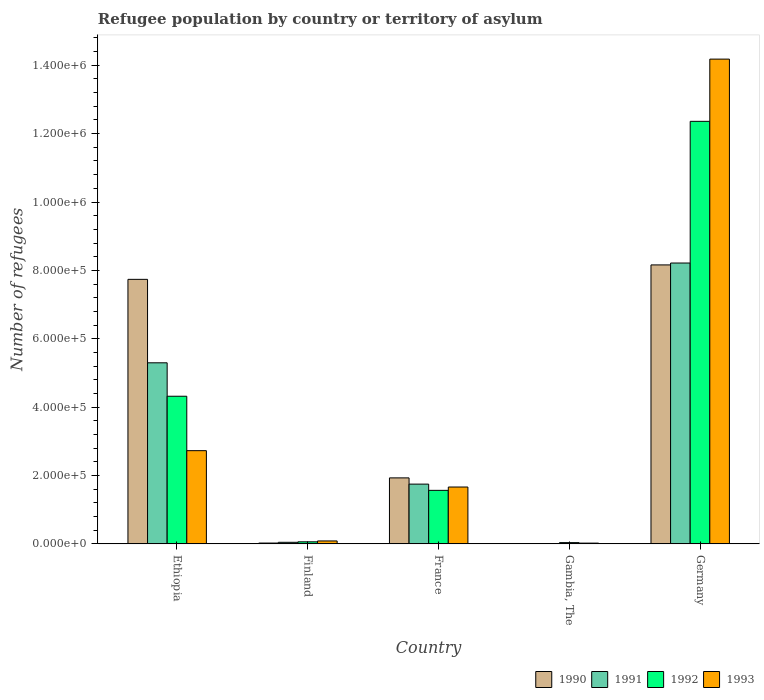How many groups of bars are there?
Offer a very short reply. 5. Are the number of bars per tick equal to the number of legend labels?
Your answer should be very brief. Yes. Are the number of bars on each tick of the X-axis equal?
Your answer should be compact. Yes. How many bars are there on the 3rd tick from the left?
Ensure brevity in your answer.  4. What is the label of the 4th group of bars from the left?
Keep it short and to the point. Gambia, The. In how many cases, is the number of bars for a given country not equal to the number of legend labels?
Offer a terse response. 0. What is the number of refugees in 1993 in Gambia, The?
Ensure brevity in your answer.  2190. Across all countries, what is the maximum number of refugees in 1991?
Your answer should be compact. 8.22e+05. In which country was the number of refugees in 1993 maximum?
Your answer should be very brief. Germany. In which country was the number of refugees in 1990 minimum?
Your answer should be very brief. Gambia, The. What is the total number of refugees in 1990 in the graph?
Ensure brevity in your answer.  1.79e+06. What is the difference between the number of refugees in 1993 in France and that in Gambia, The?
Your answer should be compact. 1.64e+05. What is the difference between the number of refugees in 1992 in Gambia, The and the number of refugees in 1990 in Germany?
Offer a terse response. -8.12e+05. What is the average number of refugees in 1990 per country?
Offer a terse response. 3.57e+05. What is the difference between the number of refugees of/in 1992 and number of refugees of/in 1990 in Finland?
Offer a very short reply. 3602. What is the ratio of the number of refugees in 1993 in France to that in Gambia, The?
Offer a very short reply. 75.92. Is the number of refugees in 1992 in Finland less than that in Gambia, The?
Make the answer very short. No. What is the difference between the highest and the second highest number of refugees in 1993?
Offer a terse response. 1.25e+06. What is the difference between the highest and the lowest number of refugees in 1992?
Offer a terse response. 1.23e+06. In how many countries, is the number of refugees in 1993 greater than the average number of refugees in 1993 taken over all countries?
Ensure brevity in your answer.  1. Is the sum of the number of refugees in 1992 in Ethiopia and France greater than the maximum number of refugees in 1990 across all countries?
Your response must be concise. No. Is it the case that in every country, the sum of the number of refugees in 1992 and number of refugees in 1991 is greater than the sum of number of refugees in 1990 and number of refugees in 1993?
Provide a succinct answer. No. What does the 2nd bar from the left in Germany represents?
Provide a succinct answer. 1991. What does the 4th bar from the right in Ethiopia represents?
Offer a very short reply. 1990. How many bars are there?
Keep it short and to the point. 20. Are all the bars in the graph horizontal?
Offer a very short reply. No. How many countries are there in the graph?
Keep it short and to the point. 5. What is the difference between two consecutive major ticks on the Y-axis?
Ensure brevity in your answer.  2.00e+05. Are the values on the major ticks of Y-axis written in scientific E-notation?
Your response must be concise. Yes. Where does the legend appear in the graph?
Offer a very short reply. Bottom right. What is the title of the graph?
Ensure brevity in your answer.  Refugee population by country or territory of asylum. What is the label or title of the X-axis?
Keep it short and to the point. Country. What is the label or title of the Y-axis?
Offer a very short reply. Number of refugees. What is the Number of refugees of 1990 in Ethiopia?
Give a very brief answer. 7.74e+05. What is the Number of refugees in 1991 in Ethiopia?
Your answer should be very brief. 5.30e+05. What is the Number of refugees in 1992 in Ethiopia?
Your answer should be compact. 4.32e+05. What is the Number of refugees of 1993 in Ethiopia?
Keep it short and to the point. 2.73e+05. What is the Number of refugees of 1990 in Finland?
Your answer should be compact. 2348. What is the Number of refugees of 1991 in Finland?
Your answer should be very brief. 4561. What is the Number of refugees in 1992 in Finland?
Offer a very short reply. 5950. What is the Number of refugees in 1993 in Finland?
Keep it short and to the point. 8511. What is the Number of refugees in 1990 in France?
Provide a succinct answer. 1.93e+05. What is the Number of refugees of 1991 in France?
Keep it short and to the point. 1.75e+05. What is the Number of refugees of 1992 in France?
Your answer should be compact. 1.57e+05. What is the Number of refugees in 1993 in France?
Keep it short and to the point. 1.66e+05. What is the Number of refugees in 1990 in Gambia, The?
Make the answer very short. 78. What is the Number of refugees of 1991 in Gambia, The?
Your answer should be very brief. 241. What is the Number of refugees of 1992 in Gambia, The?
Keep it short and to the point. 3632. What is the Number of refugees in 1993 in Gambia, The?
Your answer should be very brief. 2190. What is the Number of refugees in 1990 in Germany?
Offer a very short reply. 8.16e+05. What is the Number of refugees of 1991 in Germany?
Offer a terse response. 8.22e+05. What is the Number of refugees in 1992 in Germany?
Ensure brevity in your answer.  1.24e+06. What is the Number of refugees of 1993 in Germany?
Keep it short and to the point. 1.42e+06. Across all countries, what is the maximum Number of refugees of 1990?
Give a very brief answer. 8.16e+05. Across all countries, what is the maximum Number of refugees in 1991?
Keep it short and to the point. 8.22e+05. Across all countries, what is the maximum Number of refugees in 1992?
Your answer should be very brief. 1.24e+06. Across all countries, what is the maximum Number of refugees of 1993?
Provide a short and direct response. 1.42e+06. Across all countries, what is the minimum Number of refugees in 1990?
Provide a succinct answer. 78. Across all countries, what is the minimum Number of refugees of 1991?
Your answer should be compact. 241. Across all countries, what is the minimum Number of refugees of 1992?
Provide a short and direct response. 3632. Across all countries, what is the minimum Number of refugees in 1993?
Make the answer very short. 2190. What is the total Number of refugees in 1990 in the graph?
Give a very brief answer. 1.79e+06. What is the total Number of refugees in 1991 in the graph?
Provide a succinct answer. 1.53e+06. What is the total Number of refugees of 1992 in the graph?
Offer a terse response. 1.83e+06. What is the total Number of refugees of 1993 in the graph?
Offer a very short reply. 1.87e+06. What is the difference between the Number of refugees of 1990 in Ethiopia and that in Finland?
Provide a short and direct response. 7.71e+05. What is the difference between the Number of refugees of 1991 in Ethiopia and that in Finland?
Your answer should be compact. 5.25e+05. What is the difference between the Number of refugees in 1992 in Ethiopia and that in Finland?
Keep it short and to the point. 4.26e+05. What is the difference between the Number of refugees of 1993 in Ethiopia and that in Finland?
Offer a very short reply. 2.64e+05. What is the difference between the Number of refugees in 1990 in Ethiopia and that in France?
Offer a terse response. 5.81e+05. What is the difference between the Number of refugees of 1991 in Ethiopia and that in France?
Your answer should be compact. 3.55e+05. What is the difference between the Number of refugees in 1992 in Ethiopia and that in France?
Your answer should be compact. 2.75e+05. What is the difference between the Number of refugees in 1993 in Ethiopia and that in France?
Give a very brief answer. 1.06e+05. What is the difference between the Number of refugees of 1990 in Ethiopia and that in Gambia, The?
Ensure brevity in your answer.  7.74e+05. What is the difference between the Number of refugees of 1991 in Ethiopia and that in Gambia, The?
Your response must be concise. 5.29e+05. What is the difference between the Number of refugees of 1992 in Ethiopia and that in Gambia, The?
Keep it short and to the point. 4.28e+05. What is the difference between the Number of refugees in 1993 in Ethiopia and that in Gambia, The?
Offer a terse response. 2.70e+05. What is the difference between the Number of refugees in 1990 in Ethiopia and that in Germany?
Provide a short and direct response. -4.22e+04. What is the difference between the Number of refugees in 1991 in Ethiopia and that in Germany?
Offer a terse response. -2.92e+05. What is the difference between the Number of refugees of 1992 in Ethiopia and that in Germany?
Offer a terse response. -8.04e+05. What is the difference between the Number of refugees of 1993 in Ethiopia and that in Germany?
Provide a succinct answer. -1.15e+06. What is the difference between the Number of refugees in 1990 in Finland and that in France?
Your answer should be compact. -1.91e+05. What is the difference between the Number of refugees in 1991 in Finland and that in France?
Provide a succinct answer. -1.70e+05. What is the difference between the Number of refugees of 1992 in Finland and that in France?
Offer a very short reply. -1.51e+05. What is the difference between the Number of refugees of 1993 in Finland and that in France?
Your answer should be very brief. -1.58e+05. What is the difference between the Number of refugees in 1990 in Finland and that in Gambia, The?
Ensure brevity in your answer.  2270. What is the difference between the Number of refugees of 1991 in Finland and that in Gambia, The?
Your answer should be compact. 4320. What is the difference between the Number of refugees of 1992 in Finland and that in Gambia, The?
Keep it short and to the point. 2318. What is the difference between the Number of refugees of 1993 in Finland and that in Gambia, The?
Provide a succinct answer. 6321. What is the difference between the Number of refugees in 1990 in Finland and that in Germany?
Offer a terse response. -8.14e+05. What is the difference between the Number of refugees in 1991 in Finland and that in Germany?
Your response must be concise. -8.17e+05. What is the difference between the Number of refugees of 1992 in Finland and that in Germany?
Your response must be concise. -1.23e+06. What is the difference between the Number of refugees in 1993 in Finland and that in Germany?
Ensure brevity in your answer.  -1.41e+06. What is the difference between the Number of refugees in 1990 in France and that in Gambia, The?
Make the answer very short. 1.93e+05. What is the difference between the Number of refugees of 1991 in France and that in Gambia, The?
Ensure brevity in your answer.  1.75e+05. What is the difference between the Number of refugees of 1992 in France and that in Gambia, The?
Provide a short and direct response. 1.53e+05. What is the difference between the Number of refugees of 1993 in France and that in Gambia, The?
Keep it short and to the point. 1.64e+05. What is the difference between the Number of refugees in 1990 in France and that in Germany?
Your answer should be very brief. -6.23e+05. What is the difference between the Number of refugees in 1991 in France and that in Germany?
Provide a short and direct response. -6.47e+05. What is the difference between the Number of refugees in 1992 in France and that in Germany?
Offer a terse response. -1.08e+06. What is the difference between the Number of refugees of 1993 in France and that in Germany?
Offer a very short reply. -1.25e+06. What is the difference between the Number of refugees in 1990 in Gambia, The and that in Germany?
Your answer should be very brief. -8.16e+05. What is the difference between the Number of refugees in 1991 in Gambia, The and that in Germany?
Give a very brief answer. -8.21e+05. What is the difference between the Number of refugees of 1992 in Gambia, The and that in Germany?
Ensure brevity in your answer.  -1.23e+06. What is the difference between the Number of refugees in 1993 in Gambia, The and that in Germany?
Provide a succinct answer. -1.42e+06. What is the difference between the Number of refugees of 1990 in Ethiopia and the Number of refugees of 1991 in Finland?
Keep it short and to the point. 7.69e+05. What is the difference between the Number of refugees of 1990 in Ethiopia and the Number of refugees of 1992 in Finland?
Provide a short and direct response. 7.68e+05. What is the difference between the Number of refugees of 1990 in Ethiopia and the Number of refugees of 1993 in Finland?
Provide a short and direct response. 7.65e+05. What is the difference between the Number of refugees in 1991 in Ethiopia and the Number of refugees in 1992 in Finland?
Your answer should be compact. 5.24e+05. What is the difference between the Number of refugees of 1991 in Ethiopia and the Number of refugees of 1993 in Finland?
Ensure brevity in your answer.  5.21e+05. What is the difference between the Number of refugees in 1992 in Ethiopia and the Number of refugees in 1993 in Finland?
Your response must be concise. 4.23e+05. What is the difference between the Number of refugees in 1990 in Ethiopia and the Number of refugees in 1991 in France?
Offer a very short reply. 5.99e+05. What is the difference between the Number of refugees of 1990 in Ethiopia and the Number of refugees of 1992 in France?
Give a very brief answer. 6.17e+05. What is the difference between the Number of refugees in 1990 in Ethiopia and the Number of refugees in 1993 in France?
Your answer should be very brief. 6.07e+05. What is the difference between the Number of refugees in 1991 in Ethiopia and the Number of refugees in 1992 in France?
Offer a terse response. 3.73e+05. What is the difference between the Number of refugees of 1991 in Ethiopia and the Number of refugees of 1993 in France?
Make the answer very short. 3.63e+05. What is the difference between the Number of refugees of 1992 in Ethiopia and the Number of refugees of 1993 in France?
Keep it short and to the point. 2.66e+05. What is the difference between the Number of refugees in 1990 in Ethiopia and the Number of refugees in 1991 in Gambia, The?
Provide a short and direct response. 7.74e+05. What is the difference between the Number of refugees in 1990 in Ethiopia and the Number of refugees in 1992 in Gambia, The?
Your answer should be compact. 7.70e+05. What is the difference between the Number of refugees in 1990 in Ethiopia and the Number of refugees in 1993 in Gambia, The?
Offer a very short reply. 7.72e+05. What is the difference between the Number of refugees in 1991 in Ethiopia and the Number of refugees in 1992 in Gambia, The?
Provide a succinct answer. 5.26e+05. What is the difference between the Number of refugees of 1991 in Ethiopia and the Number of refugees of 1993 in Gambia, The?
Make the answer very short. 5.27e+05. What is the difference between the Number of refugees in 1992 in Ethiopia and the Number of refugees in 1993 in Gambia, The?
Your response must be concise. 4.30e+05. What is the difference between the Number of refugees in 1990 in Ethiopia and the Number of refugees in 1991 in Germany?
Your response must be concise. -4.77e+04. What is the difference between the Number of refugees of 1990 in Ethiopia and the Number of refugees of 1992 in Germany?
Your response must be concise. -4.62e+05. What is the difference between the Number of refugees in 1990 in Ethiopia and the Number of refugees in 1993 in Germany?
Your answer should be compact. -6.44e+05. What is the difference between the Number of refugees in 1991 in Ethiopia and the Number of refugees in 1992 in Germany?
Offer a very short reply. -7.06e+05. What is the difference between the Number of refugees in 1991 in Ethiopia and the Number of refugees in 1993 in Germany?
Keep it short and to the point. -8.88e+05. What is the difference between the Number of refugees in 1992 in Ethiopia and the Number of refugees in 1993 in Germany?
Ensure brevity in your answer.  -9.86e+05. What is the difference between the Number of refugees of 1990 in Finland and the Number of refugees of 1991 in France?
Offer a very short reply. -1.72e+05. What is the difference between the Number of refugees of 1990 in Finland and the Number of refugees of 1992 in France?
Offer a very short reply. -1.54e+05. What is the difference between the Number of refugees of 1990 in Finland and the Number of refugees of 1993 in France?
Provide a succinct answer. -1.64e+05. What is the difference between the Number of refugees in 1991 in Finland and the Number of refugees in 1992 in France?
Offer a terse response. -1.52e+05. What is the difference between the Number of refugees of 1991 in Finland and the Number of refugees of 1993 in France?
Ensure brevity in your answer.  -1.62e+05. What is the difference between the Number of refugees in 1992 in Finland and the Number of refugees in 1993 in France?
Your response must be concise. -1.60e+05. What is the difference between the Number of refugees of 1990 in Finland and the Number of refugees of 1991 in Gambia, The?
Make the answer very short. 2107. What is the difference between the Number of refugees in 1990 in Finland and the Number of refugees in 1992 in Gambia, The?
Make the answer very short. -1284. What is the difference between the Number of refugees of 1990 in Finland and the Number of refugees of 1993 in Gambia, The?
Offer a very short reply. 158. What is the difference between the Number of refugees in 1991 in Finland and the Number of refugees in 1992 in Gambia, The?
Keep it short and to the point. 929. What is the difference between the Number of refugees in 1991 in Finland and the Number of refugees in 1993 in Gambia, The?
Provide a short and direct response. 2371. What is the difference between the Number of refugees in 1992 in Finland and the Number of refugees in 1993 in Gambia, The?
Your answer should be very brief. 3760. What is the difference between the Number of refugees in 1990 in Finland and the Number of refugees in 1991 in Germany?
Ensure brevity in your answer.  -8.19e+05. What is the difference between the Number of refugees in 1990 in Finland and the Number of refugees in 1992 in Germany?
Provide a succinct answer. -1.23e+06. What is the difference between the Number of refugees of 1990 in Finland and the Number of refugees of 1993 in Germany?
Give a very brief answer. -1.42e+06. What is the difference between the Number of refugees of 1991 in Finland and the Number of refugees of 1992 in Germany?
Your answer should be very brief. -1.23e+06. What is the difference between the Number of refugees of 1991 in Finland and the Number of refugees of 1993 in Germany?
Your response must be concise. -1.41e+06. What is the difference between the Number of refugees of 1992 in Finland and the Number of refugees of 1993 in Germany?
Your answer should be compact. -1.41e+06. What is the difference between the Number of refugees of 1990 in France and the Number of refugees of 1991 in Gambia, The?
Offer a terse response. 1.93e+05. What is the difference between the Number of refugees in 1990 in France and the Number of refugees in 1992 in Gambia, The?
Provide a succinct answer. 1.89e+05. What is the difference between the Number of refugees of 1990 in France and the Number of refugees of 1993 in Gambia, The?
Your answer should be compact. 1.91e+05. What is the difference between the Number of refugees of 1991 in France and the Number of refugees of 1992 in Gambia, The?
Provide a succinct answer. 1.71e+05. What is the difference between the Number of refugees of 1991 in France and the Number of refugees of 1993 in Gambia, The?
Keep it short and to the point. 1.73e+05. What is the difference between the Number of refugees of 1992 in France and the Number of refugees of 1993 in Gambia, The?
Offer a very short reply. 1.54e+05. What is the difference between the Number of refugees of 1990 in France and the Number of refugees of 1991 in Germany?
Keep it short and to the point. -6.28e+05. What is the difference between the Number of refugees of 1990 in France and the Number of refugees of 1992 in Germany?
Keep it short and to the point. -1.04e+06. What is the difference between the Number of refugees in 1990 in France and the Number of refugees in 1993 in Germany?
Ensure brevity in your answer.  -1.22e+06. What is the difference between the Number of refugees in 1991 in France and the Number of refugees in 1992 in Germany?
Your answer should be compact. -1.06e+06. What is the difference between the Number of refugees in 1991 in France and the Number of refugees in 1993 in Germany?
Ensure brevity in your answer.  -1.24e+06. What is the difference between the Number of refugees in 1992 in France and the Number of refugees in 1993 in Germany?
Your response must be concise. -1.26e+06. What is the difference between the Number of refugees of 1990 in Gambia, The and the Number of refugees of 1991 in Germany?
Offer a terse response. -8.21e+05. What is the difference between the Number of refugees in 1990 in Gambia, The and the Number of refugees in 1992 in Germany?
Give a very brief answer. -1.24e+06. What is the difference between the Number of refugees in 1990 in Gambia, The and the Number of refugees in 1993 in Germany?
Your answer should be very brief. -1.42e+06. What is the difference between the Number of refugees in 1991 in Gambia, The and the Number of refugees in 1992 in Germany?
Your response must be concise. -1.24e+06. What is the difference between the Number of refugees in 1991 in Gambia, The and the Number of refugees in 1993 in Germany?
Give a very brief answer. -1.42e+06. What is the difference between the Number of refugees of 1992 in Gambia, The and the Number of refugees of 1993 in Germany?
Provide a short and direct response. -1.41e+06. What is the average Number of refugees in 1990 per country?
Your answer should be very brief. 3.57e+05. What is the average Number of refugees of 1991 per country?
Offer a very short reply. 3.06e+05. What is the average Number of refugees in 1992 per country?
Your response must be concise. 3.67e+05. What is the average Number of refugees of 1993 per country?
Your answer should be very brief. 3.74e+05. What is the difference between the Number of refugees of 1990 and Number of refugees of 1991 in Ethiopia?
Your answer should be very brief. 2.44e+05. What is the difference between the Number of refugees in 1990 and Number of refugees in 1992 in Ethiopia?
Your answer should be very brief. 3.42e+05. What is the difference between the Number of refugees in 1990 and Number of refugees in 1993 in Ethiopia?
Keep it short and to the point. 5.01e+05. What is the difference between the Number of refugees in 1991 and Number of refugees in 1992 in Ethiopia?
Ensure brevity in your answer.  9.78e+04. What is the difference between the Number of refugees of 1991 and Number of refugees of 1993 in Ethiopia?
Provide a short and direct response. 2.57e+05. What is the difference between the Number of refugees in 1992 and Number of refugees in 1993 in Ethiopia?
Ensure brevity in your answer.  1.59e+05. What is the difference between the Number of refugees of 1990 and Number of refugees of 1991 in Finland?
Your answer should be compact. -2213. What is the difference between the Number of refugees in 1990 and Number of refugees in 1992 in Finland?
Your response must be concise. -3602. What is the difference between the Number of refugees of 1990 and Number of refugees of 1993 in Finland?
Provide a succinct answer. -6163. What is the difference between the Number of refugees in 1991 and Number of refugees in 1992 in Finland?
Ensure brevity in your answer.  -1389. What is the difference between the Number of refugees in 1991 and Number of refugees in 1993 in Finland?
Keep it short and to the point. -3950. What is the difference between the Number of refugees of 1992 and Number of refugees of 1993 in Finland?
Keep it short and to the point. -2561. What is the difference between the Number of refugees in 1990 and Number of refugees in 1991 in France?
Offer a terse response. 1.82e+04. What is the difference between the Number of refugees in 1990 and Number of refugees in 1992 in France?
Your response must be concise. 3.65e+04. What is the difference between the Number of refugees in 1990 and Number of refugees in 1993 in France?
Offer a very short reply. 2.67e+04. What is the difference between the Number of refugees in 1991 and Number of refugees in 1992 in France?
Ensure brevity in your answer.  1.82e+04. What is the difference between the Number of refugees of 1991 and Number of refugees of 1993 in France?
Provide a short and direct response. 8487. What is the difference between the Number of refugees in 1992 and Number of refugees in 1993 in France?
Provide a succinct answer. -9757. What is the difference between the Number of refugees of 1990 and Number of refugees of 1991 in Gambia, The?
Your answer should be very brief. -163. What is the difference between the Number of refugees in 1990 and Number of refugees in 1992 in Gambia, The?
Your answer should be compact. -3554. What is the difference between the Number of refugees of 1990 and Number of refugees of 1993 in Gambia, The?
Your answer should be very brief. -2112. What is the difference between the Number of refugees of 1991 and Number of refugees of 1992 in Gambia, The?
Your response must be concise. -3391. What is the difference between the Number of refugees of 1991 and Number of refugees of 1993 in Gambia, The?
Provide a short and direct response. -1949. What is the difference between the Number of refugees of 1992 and Number of refugees of 1993 in Gambia, The?
Provide a short and direct response. 1442. What is the difference between the Number of refugees of 1990 and Number of refugees of 1991 in Germany?
Give a very brief answer. -5500. What is the difference between the Number of refugees of 1990 and Number of refugees of 1992 in Germany?
Offer a very short reply. -4.20e+05. What is the difference between the Number of refugees in 1990 and Number of refugees in 1993 in Germany?
Your answer should be compact. -6.02e+05. What is the difference between the Number of refugees in 1991 and Number of refugees in 1992 in Germany?
Your answer should be compact. -4.14e+05. What is the difference between the Number of refugees of 1991 and Number of refugees of 1993 in Germany?
Provide a succinct answer. -5.96e+05. What is the difference between the Number of refugees of 1992 and Number of refugees of 1993 in Germany?
Make the answer very short. -1.82e+05. What is the ratio of the Number of refugees of 1990 in Ethiopia to that in Finland?
Offer a terse response. 329.54. What is the ratio of the Number of refugees in 1991 in Ethiopia to that in Finland?
Offer a very short reply. 116.12. What is the ratio of the Number of refugees in 1992 in Ethiopia to that in Finland?
Your answer should be very brief. 72.58. What is the ratio of the Number of refugees of 1993 in Ethiopia to that in Finland?
Your answer should be very brief. 32.03. What is the ratio of the Number of refugees of 1990 in Ethiopia to that in France?
Your answer should be very brief. 4.01. What is the ratio of the Number of refugees of 1991 in Ethiopia to that in France?
Provide a succinct answer. 3.03. What is the ratio of the Number of refugees in 1992 in Ethiopia to that in France?
Offer a very short reply. 2.76. What is the ratio of the Number of refugees of 1993 in Ethiopia to that in France?
Provide a short and direct response. 1.64. What is the ratio of the Number of refugees in 1990 in Ethiopia to that in Gambia, The?
Ensure brevity in your answer.  9920.05. What is the ratio of the Number of refugees of 1991 in Ethiopia to that in Gambia, The?
Give a very brief answer. 2197.59. What is the ratio of the Number of refugees in 1992 in Ethiopia to that in Gambia, The?
Offer a very short reply. 118.89. What is the ratio of the Number of refugees of 1993 in Ethiopia to that in Gambia, The?
Your answer should be very brief. 124.49. What is the ratio of the Number of refugees of 1990 in Ethiopia to that in Germany?
Provide a short and direct response. 0.95. What is the ratio of the Number of refugees in 1991 in Ethiopia to that in Germany?
Ensure brevity in your answer.  0.64. What is the ratio of the Number of refugees of 1992 in Ethiopia to that in Germany?
Offer a terse response. 0.35. What is the ratio of the Number of refugees of 1993 in Ethiopia to that in Germany?
Offer a terse response. 0.19. What is the ratio of the Number of refugees of 1990 in Finland to that in France?
Your response must be concise. 0.01. What is the ratio of the Number of refugees in 1991 in Finland to that in France?
Give a very brief answer. 0.03. What is the ratio of the Number of refugees in 1992 in Finland to that in France?
Keep it short and to the point. 0.04. What is the ratio of the Number of refugees in 1993 in Finland to that in France?
Ensure brevity in your answer.  0.05. What is the ratio of the Number of refugees of 1990 in Finland to that in Gambia, The?
Ensure brevity in your answer.  30.1. What is the ratio of the Number of refugees of 1991 in Finland to that in Gambia, The?
Give a very brief answer. 18.93. What is the ratio of the Number of refugees in 1992 in Finland to that in Gambia, The?
Provide a succinct answer. 1.64. What is the ratio of the Number of refugees of 1993 in Finland to that in Gambia, The?
Your response must be concise. 3.89. What is the ratio of the Number of refugees in 1990 in Finland to that in Germany?
Keep it short and to the point. 0. What is the ratio of the Number of refugees of 1991 in Finland to that in Germany?
Your response must be concise. 0.01. What is the ratio of the Number of refugees of 1992 in Finland to that in Germany?
Offer a terse response. 0. What is the ratio of the Number of refugees of 1993 in Finland to that in Germany?
Provide a short and direct response. 0.01. What is the ratio of the Number of refugees of 1990 in France to that in Gambia, The?
Offer a very short reply. 2474.36. What is the ratio of the Number of refugees in 1991 in France to that in Gambia, The?
Your response must be concise. 725.13. What is the ratio of the Number of refugees of 1992 in France to that in Gambia, The?
Your answer should be very brief. 43.09. What is the ratio of the Number of refugees of 1993 in France to that in Gambia, The?
Offer a very short reply. 75.92. What is the ratio of the Number of refugees of 1990 in France to that in Germany?
Offer a terse response. 0.24. What is the ratio of the Number of refugees of 1991 in France to that in Germany?
Keep it short and to the point. 0.21. What is the ratio of the Number of refugees of 1992 in France to that in Germany?
Keep it short and to the point. 0.13. What is the ratio of the Number of refugees of 1993 in France to that in Germany?
Provide a short and direct response. 0.12. What is the ratio of the Number of refugees in 1990 in Gambia, The to that in Germany?
Offer a terse response. 0. What is the ratio of the Number of refugees of 1992 in Gambia, The to that in Germany?
Your response must be concise. 0. What is the ratio of the Number of refugees in 1993 in Gambia, The to that in Germany?
Your response must be concise. 0. What is the difference between the highest and the second highest Number of refugees of 1990?
Your answer should be compact. 4.22e+04. What is the difference between the highest and the second highest Number of refugees in 1991?
Your answer should be very brief. 2.92e+05. What is the difference between the highest and the second highest Number of refugees in 1992?
Ensure brevity in your answer.  8.04e+05. What is the difference between the highest and the second highest Number of refugees in 1993?
Ensure brevity in your answer.  1.15e+06. What is the difference between the highest and the lowest Number of refugees of 1990?
Your response must be concise. 8.16e+05. What is the difference between the highest and the lowest Number of refugees in 1991?
Provide a short and direct response. 8.21e+05. What is the difference between the highest and the lowest Number of refugees in 1992?
Give a very brief answer. 1.23e+06. What is the difference between the highest and the lowest Number of refugees of 1993?
Offer a very short reply. 1.42e+06. 